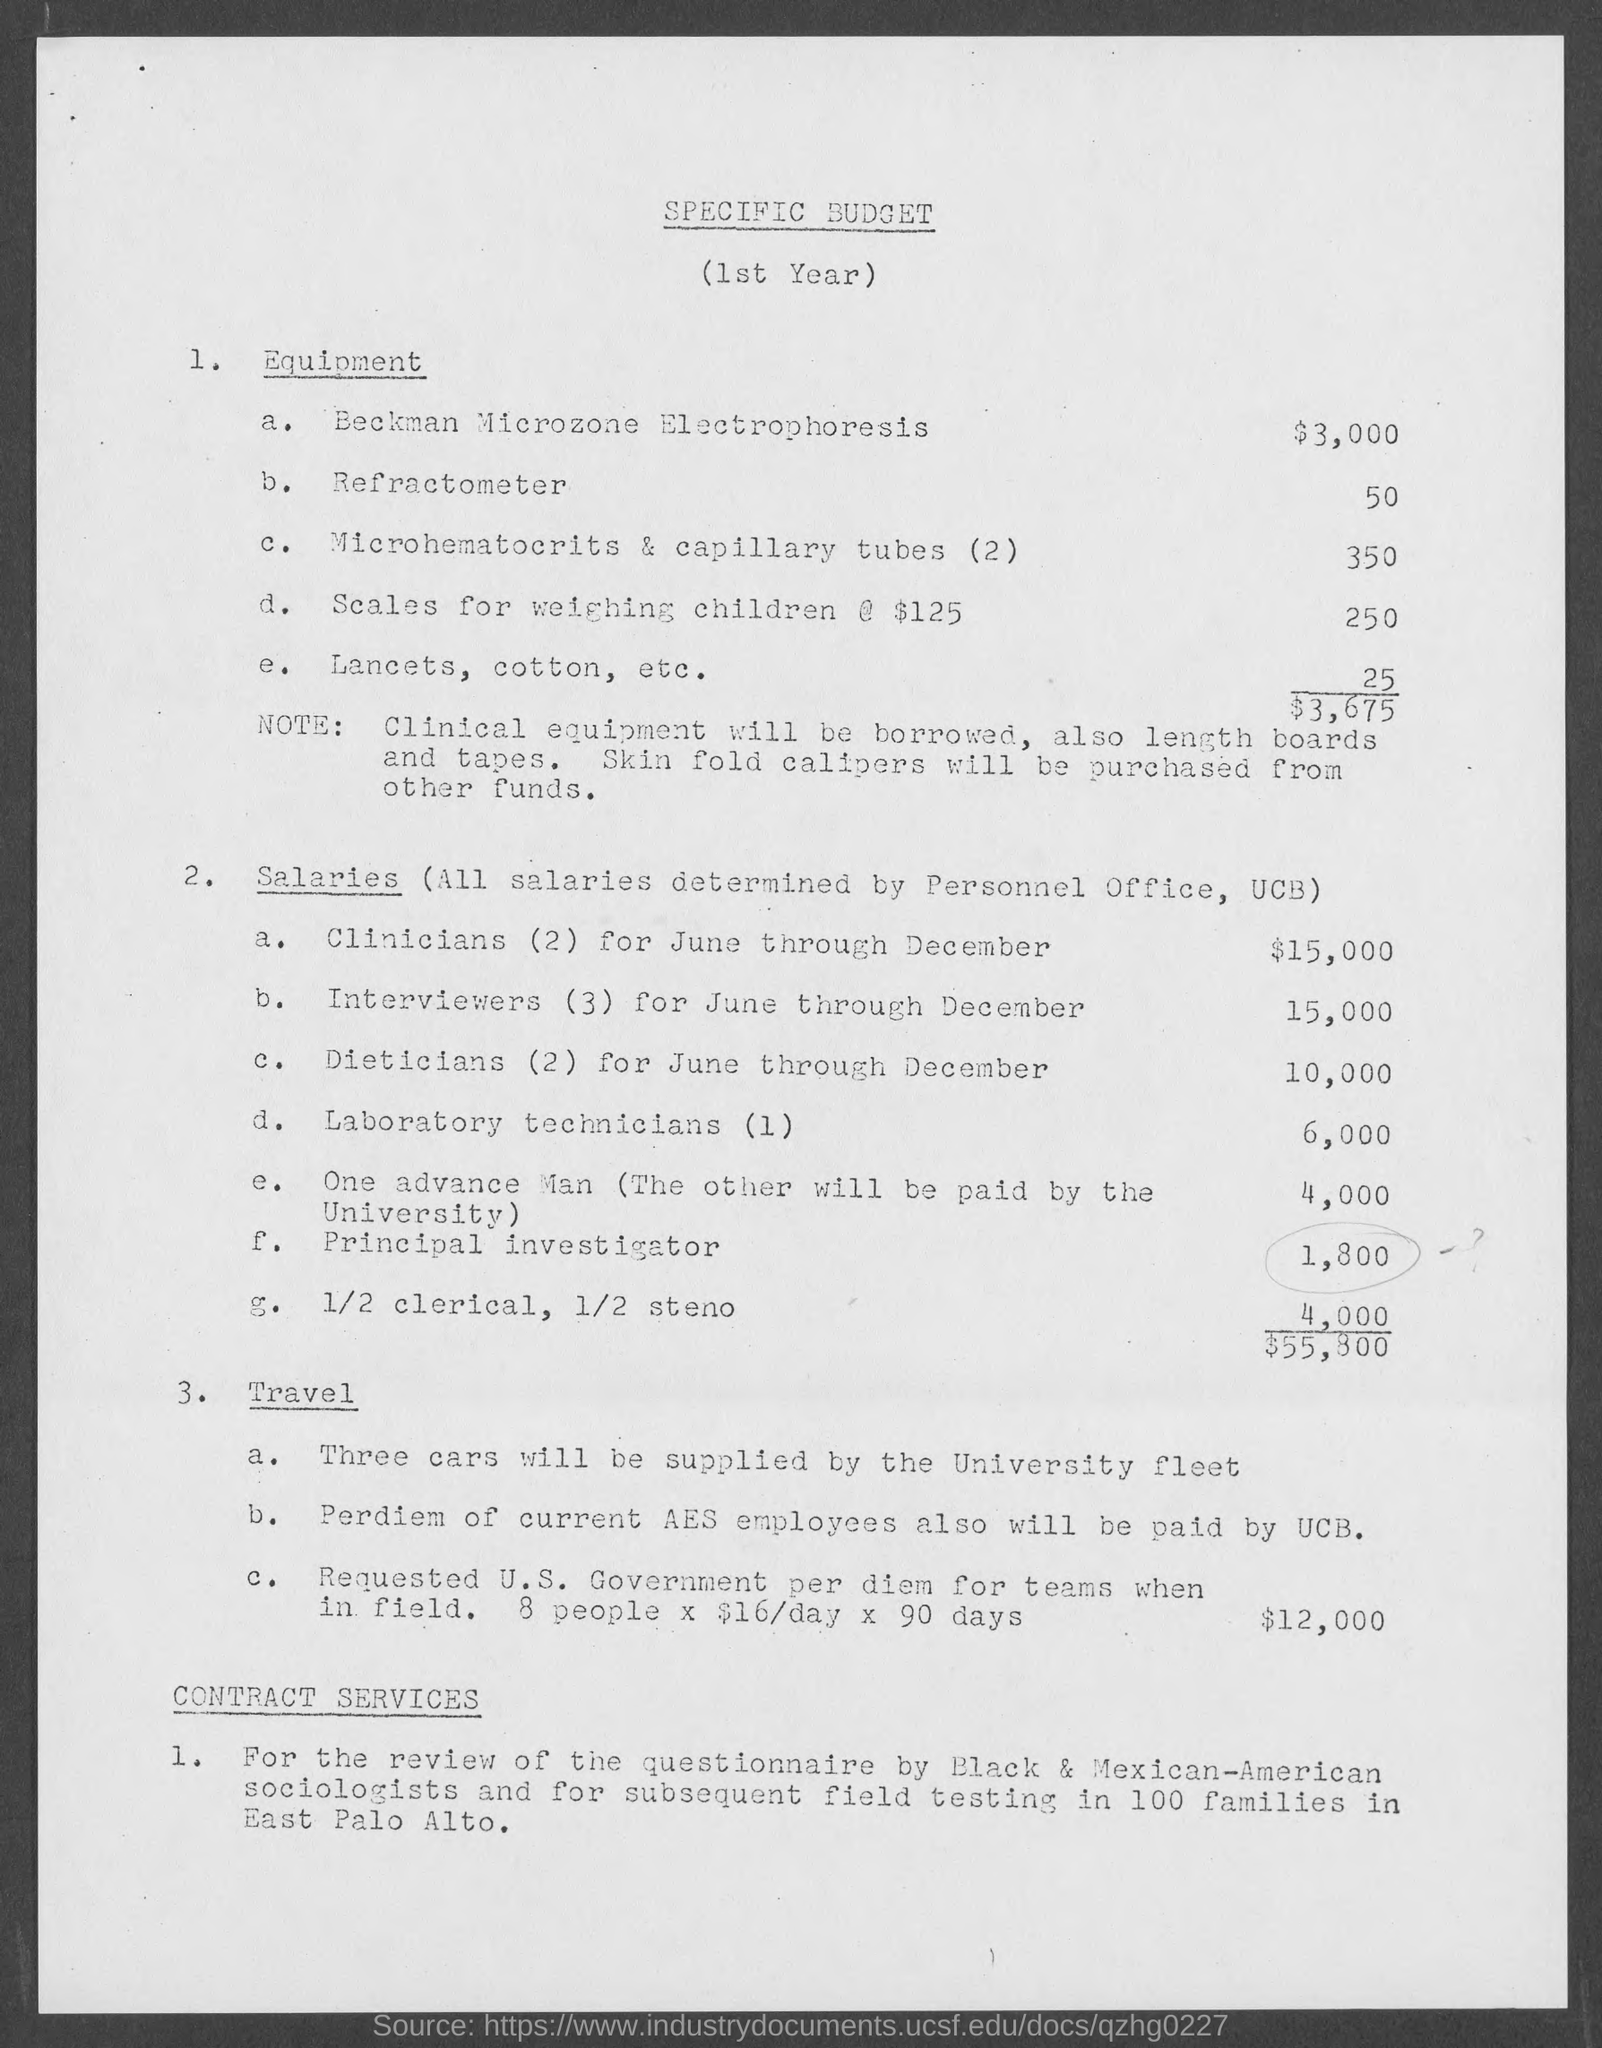Can you describe what is itemized under the salaries section? Certainly! The salaries section outlines payments for various personnel for June through December. It includes $15,000 for two clinicians, the same amount for three interviewers, $10,000 for two dieticians, $6,000 for one laboratory technician, $4,000 for one advance man, $1,800 for a principal investigator, and $4,000 for 1/2 clerical and 1/2 steno, totaling $55,800. 